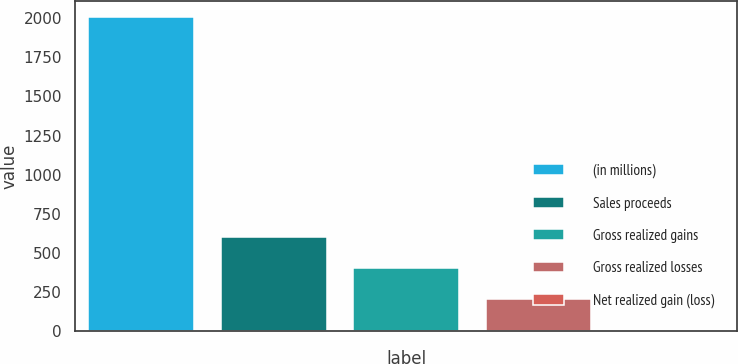<chart> <loc_0><loc_0><loc_500><loc_500><bar_chart><fcel>(in millions)<fcel>Sales proceeds<fcel>Gross realized gains<fcel>Gross realized losses<fcel>Net realized gain (loss)<nl><fcel>2011<fcel>604<fcel>403<fcel>202<fcel>1<nl></chart> 